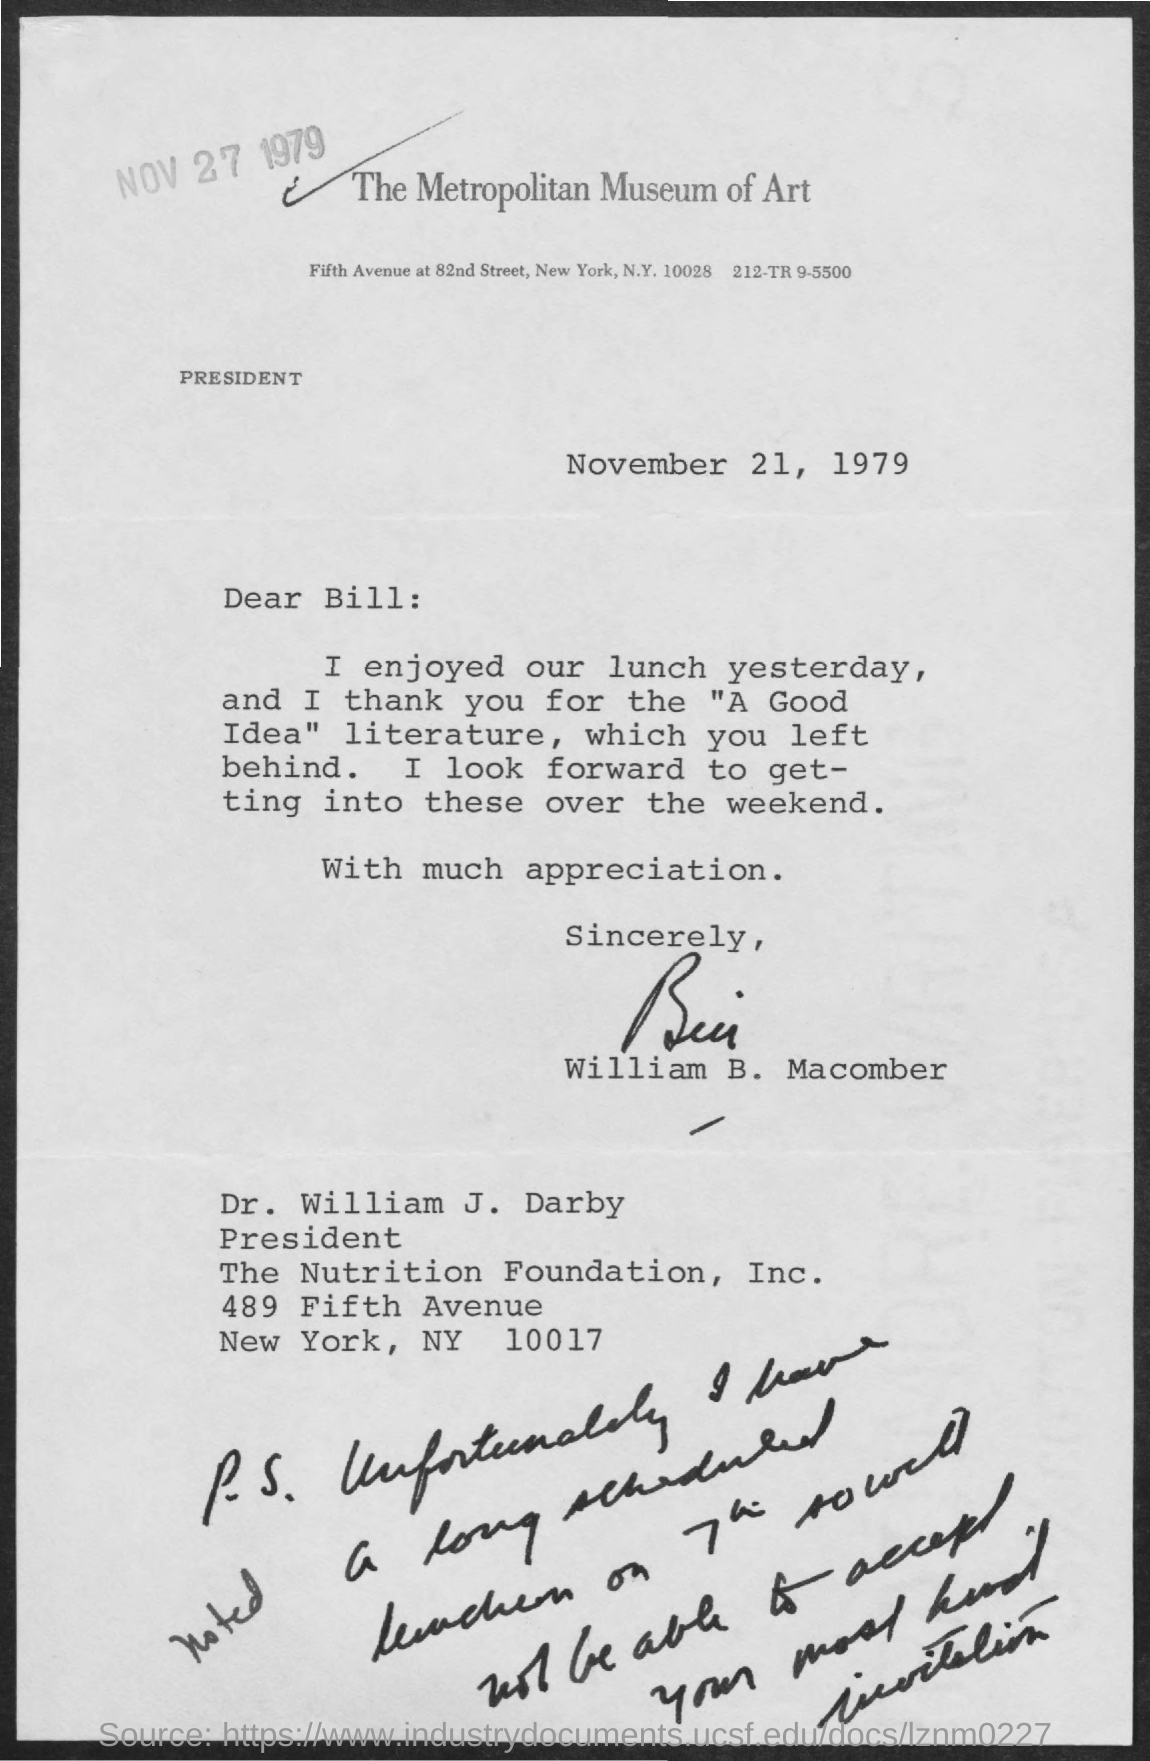Give some essential details in this illustration. The letter was dated November 21, 1979. Dr. William J. Darby is designated as the President. The Metropolitan Museum of Art is mentioned in the letterhead of a company. The letter has been signed by William B. Macomber. The letter is addressed to Bill. 